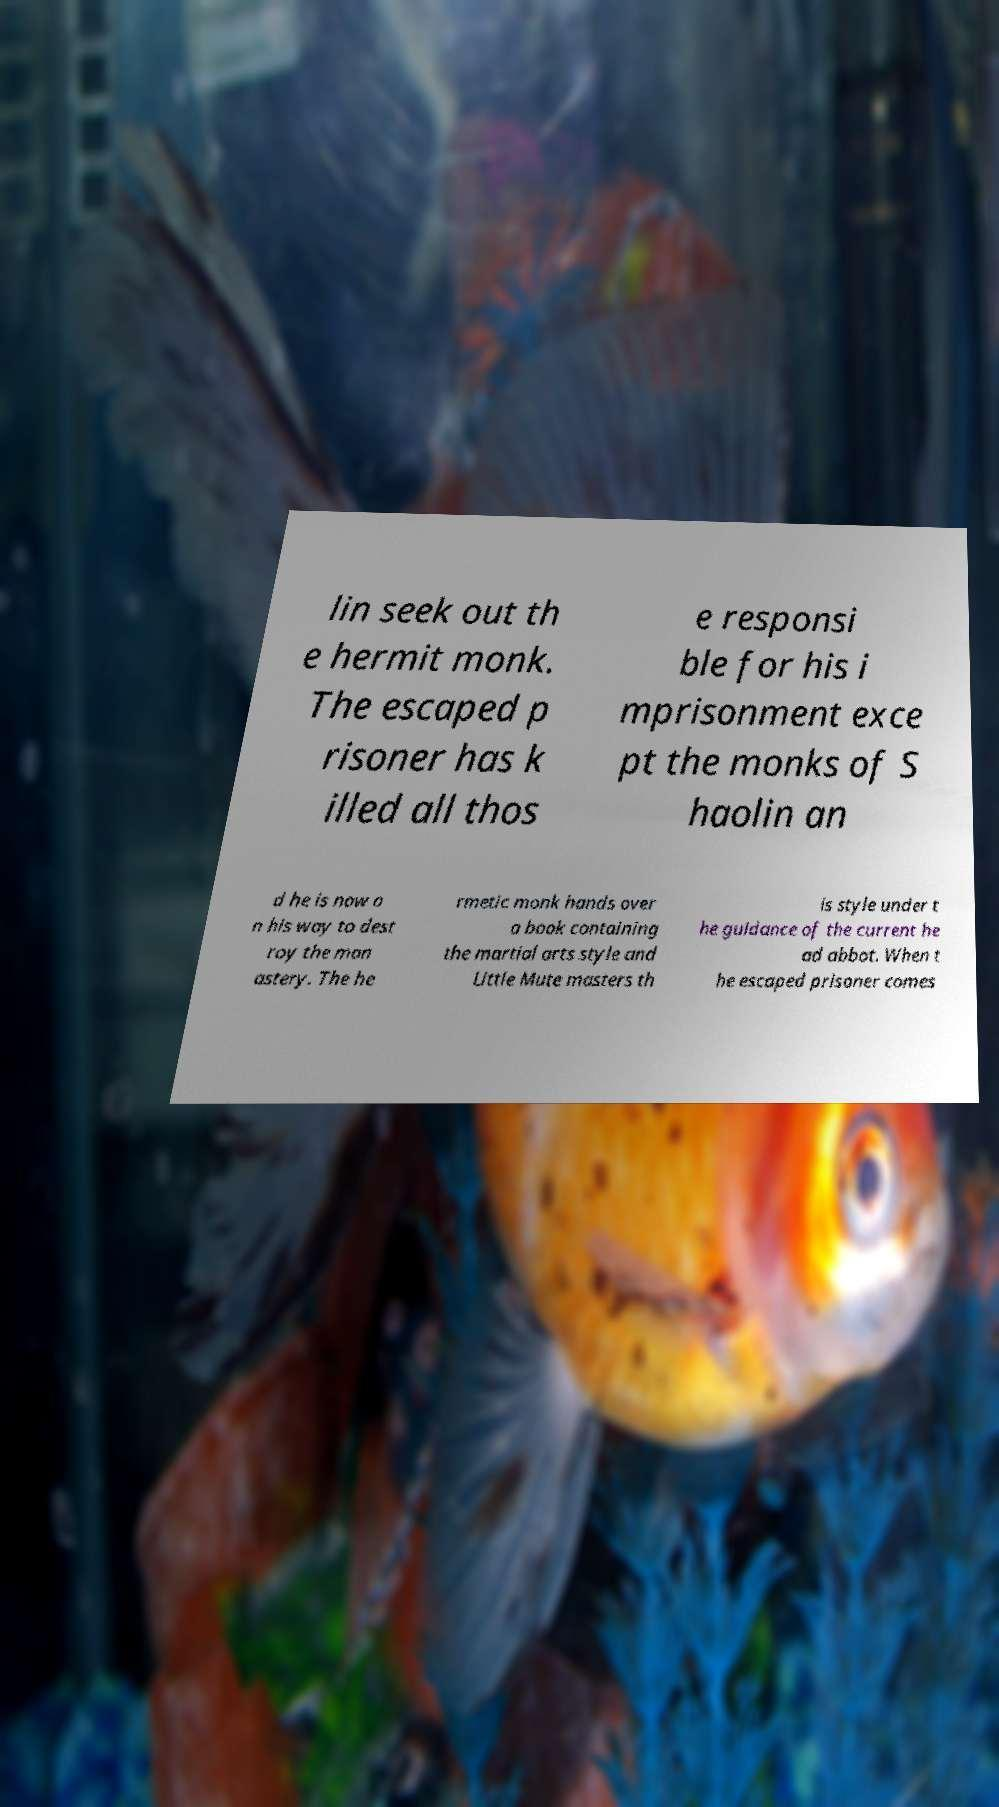There's text embedded in this image that I need extracted. Can you transcribe it verbatim? lin seek out th e hermit monk. The escaped p risoner has k illed all thos e responsi ble for his i mprisonment exce pt the monks of S haolin an d he is now o n his way to dest roy the mon astery. The he rmetic monk hands over a book containing the martial arts style and Little Mute masters th is style under t he guidance of the current he ad abbot. When t he escaped prisoner comes 